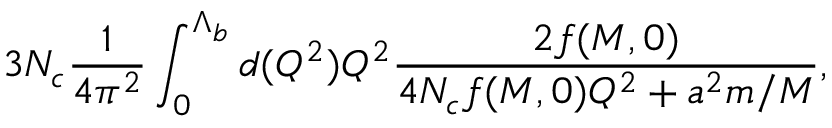<formula> <loc_0><loc_0><loc_500><loc_500>3 N _ { c } \frac { 1 } { 4 \pi ^ { 2 } } \int _ { 0 } ^ { \Lambda _ { b } } d ( Q ^ { 2 } ) Q ^ { 2 } \frac { 2 f ( M , 0 ) } { 4 N _ { c } f ( M , 0 ) Q ^ { 2 } + a ^ { 2 } m / M } ,</formula> 